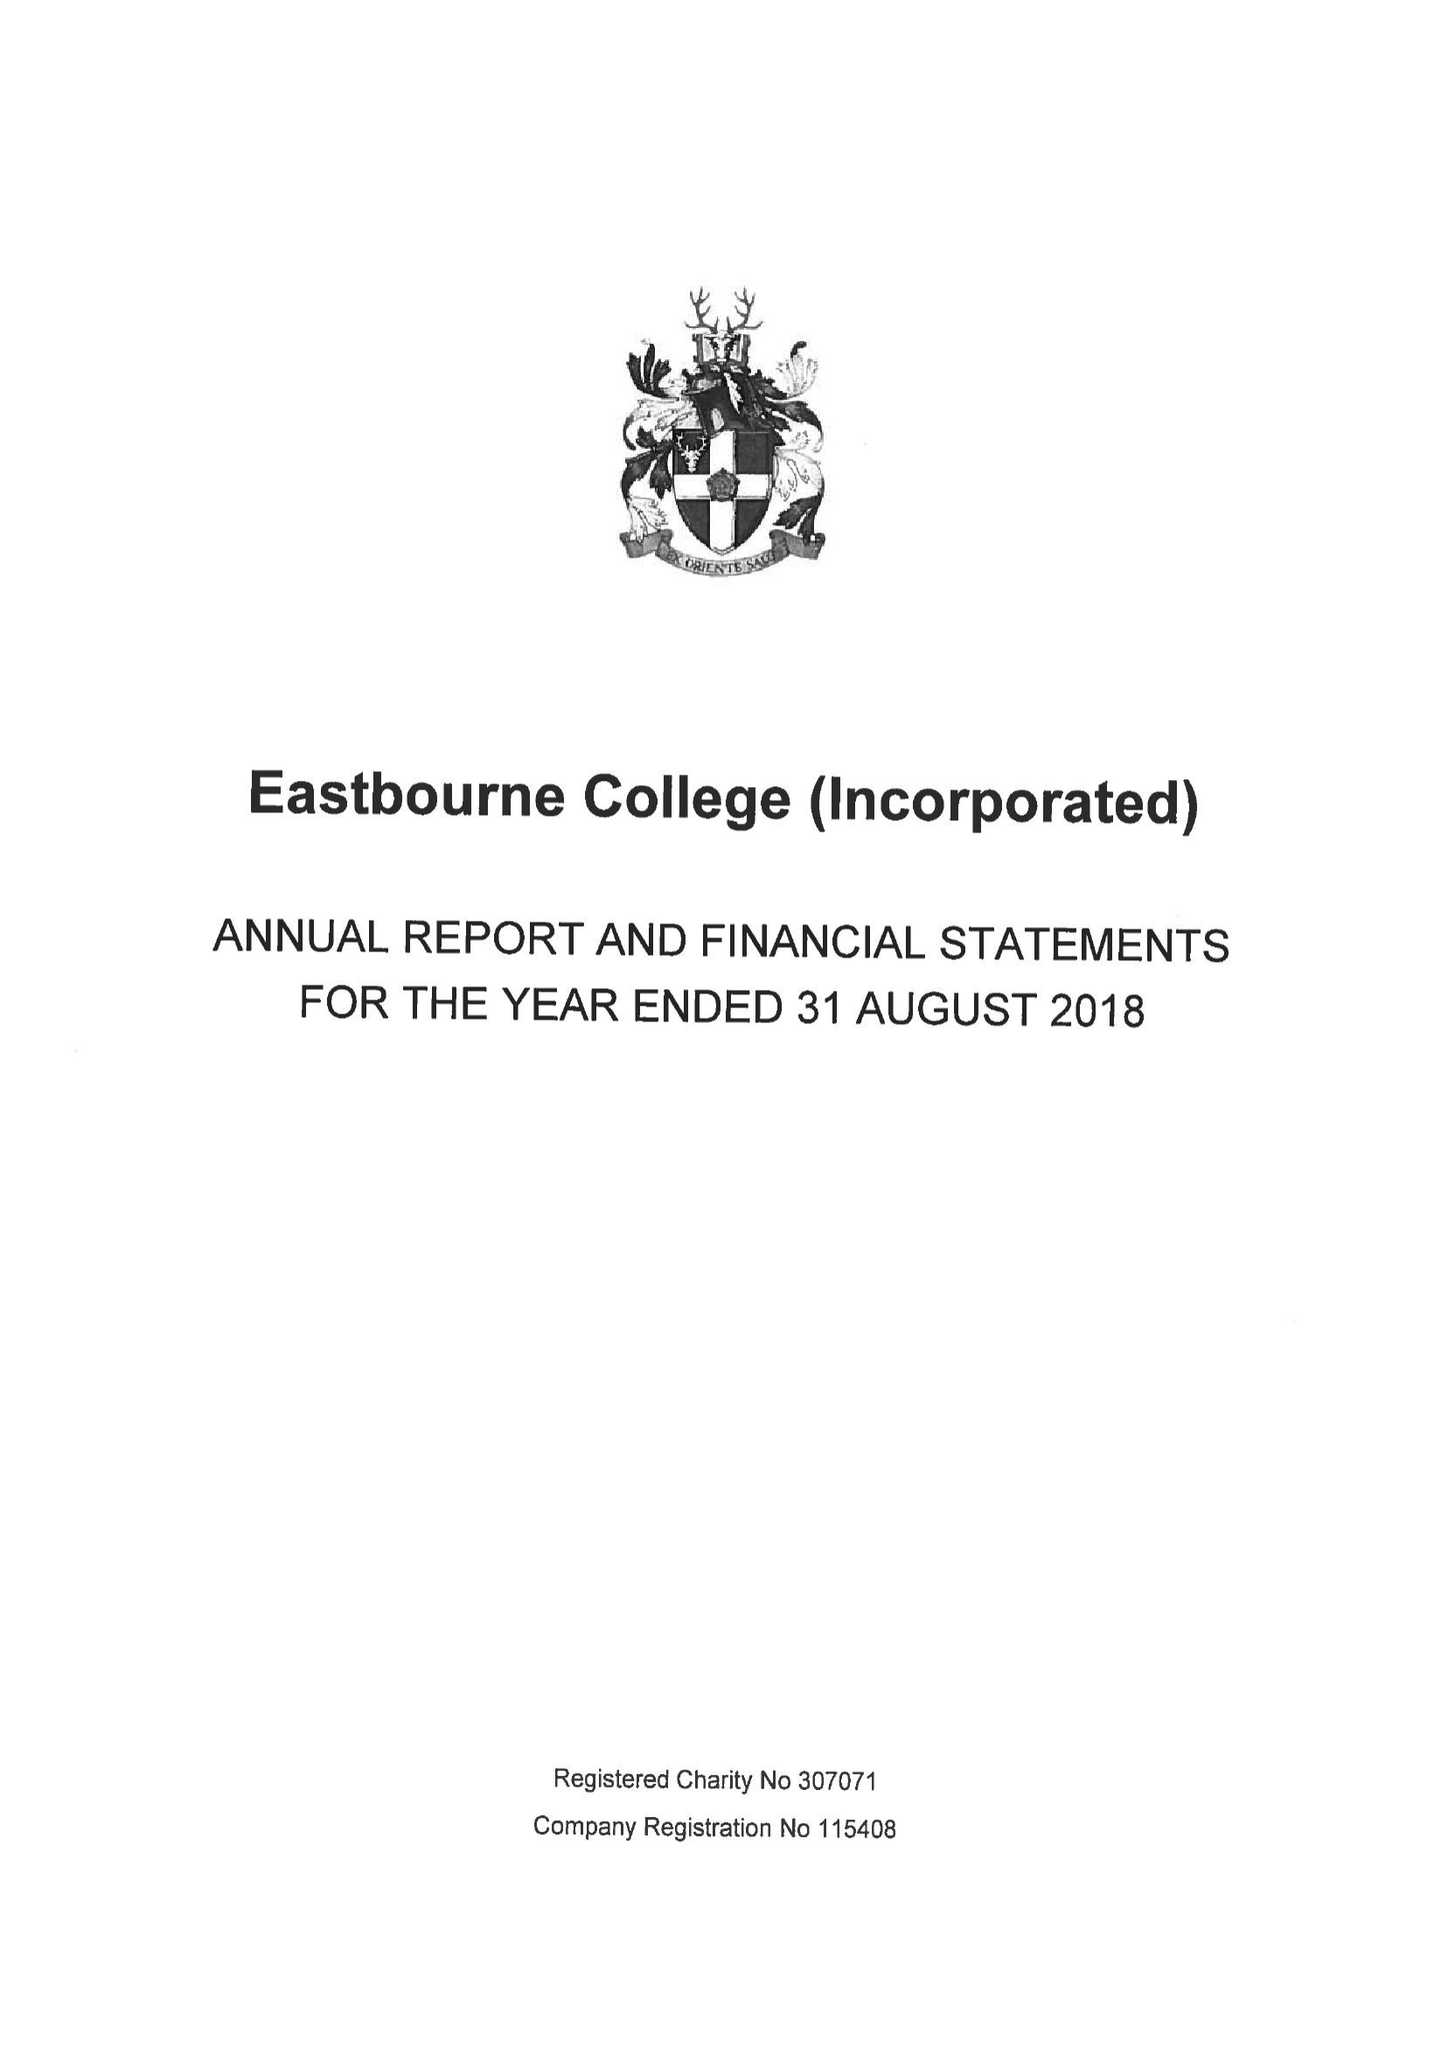What is the value for the address__post_town?
Answer the question using a single word or phrase. EASTBOURNE 